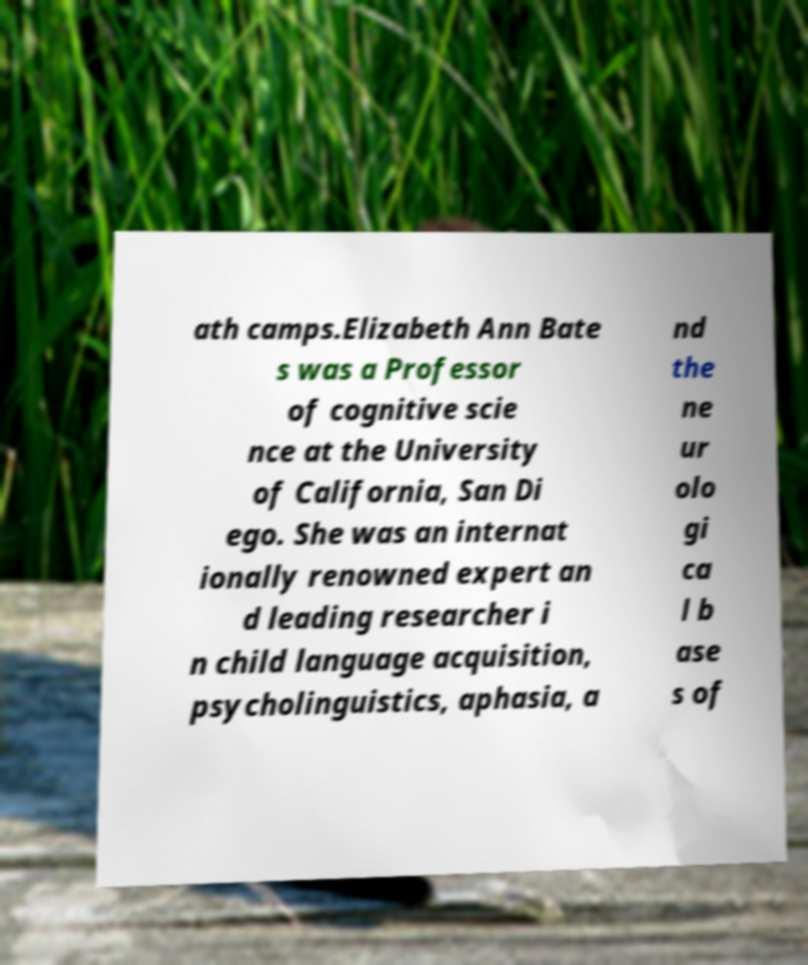Can you accurately transcribe the text from the provided image for me? ath camps.Elizabeth Ann Bate s was a Professor of cognitive scie nce at the University of California, San Di ego. She was an internat ionally renowned expert an d leading researcher i n child language acquisition, psycholinguistics, aphasia, a nd the ne ur olo gi ca l b ase s of 